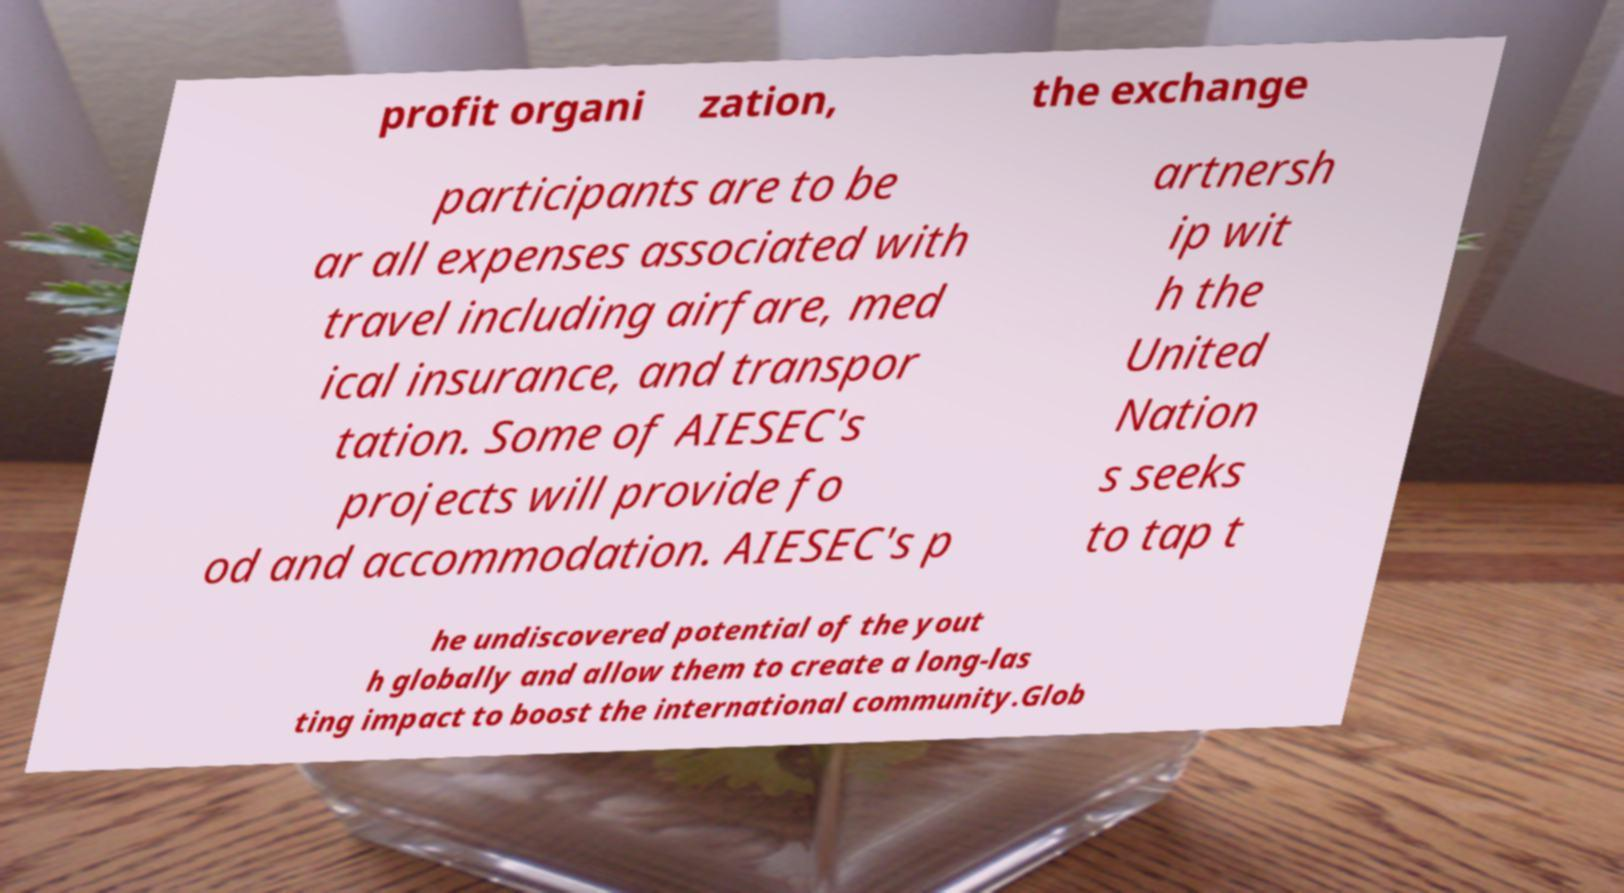Can you accurately transcribe the text from the provided image for me? profit organi zation, the exchange participants are to be ar all expenses associated with travel including airfare, med ical insurance, and transpor tation. Some of AIESEC's projects will provide fo od and accommodation. AIESEC's p artnersh ip wit h the United Nation s seeks to tap t he undiscovered potential of the yout h globally and allow them to create a long-las ting impact to boost the international community.Glob 